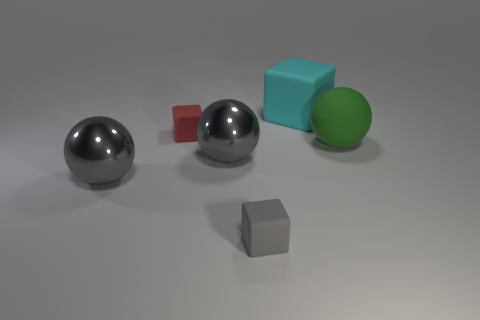Is there any indication of the texture of the materials present in the image? Yes, the texture of the materials can be inferred by the way light interacts with their surfaces. The spheres have reflective surfaces suggesting a smooth, possibly metallic texture, whereas the cyan and green blocks appear to have a slightly grainy texture suggesting a rubber or plastic material. 